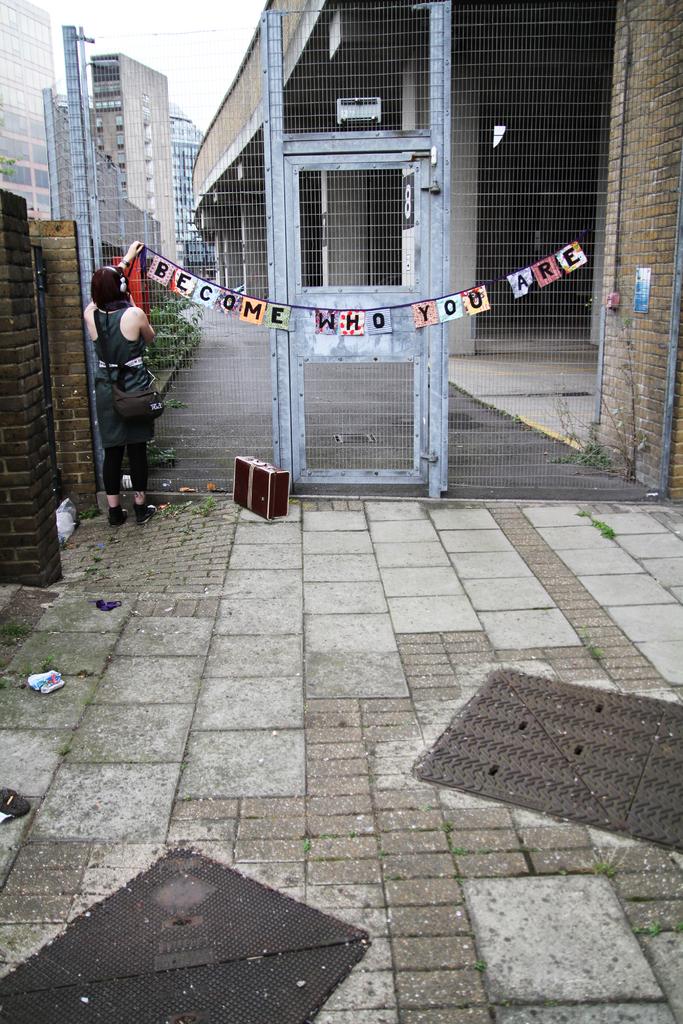What do they want you to do?
Offer a very short reply. Become who you are. Who do they want to welcome?
Keep it short and to the point. Unanswerable. 